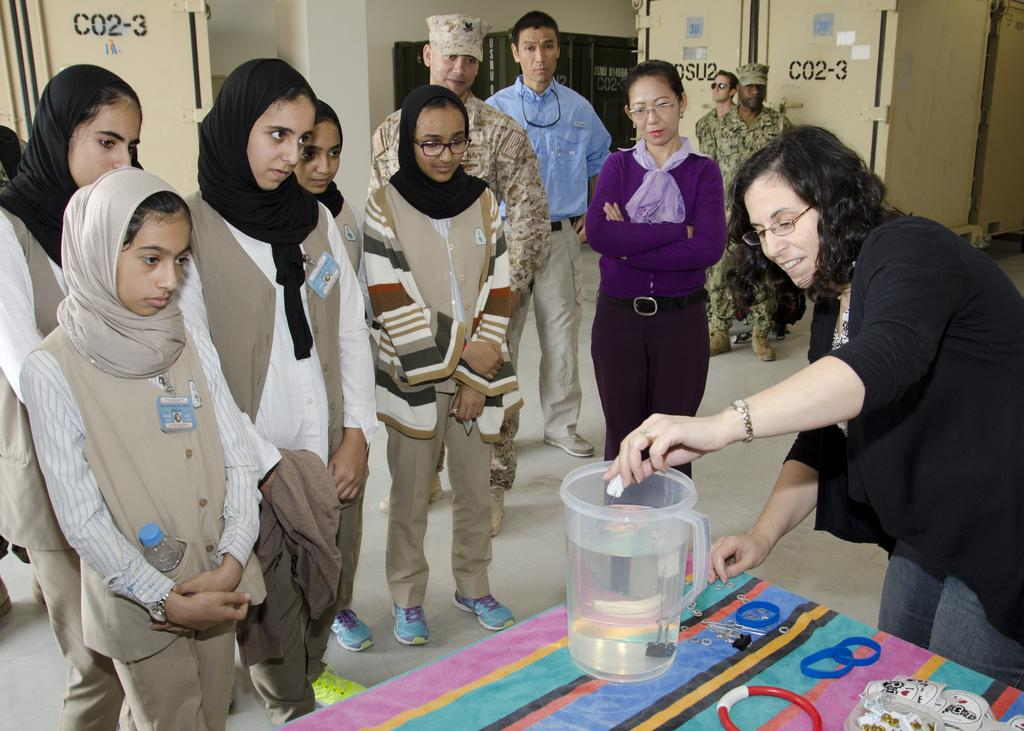<image>
Render a clear and concise summary of the photo. A bunch of people gather with CO2-3 written on the walls. 